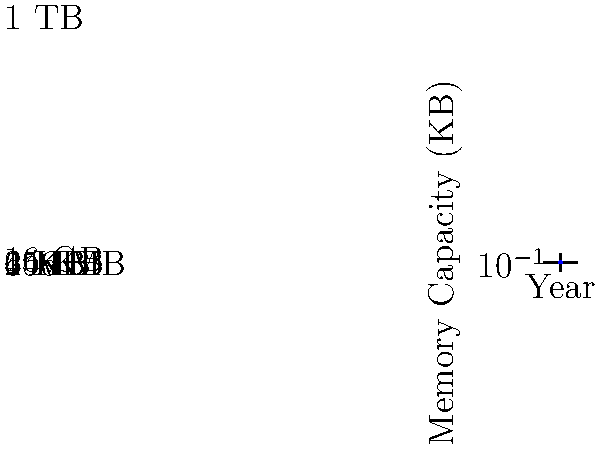As a vintage computer collector, you've observed the evolution of computer memory capacity over time. The graph shows this progression from 1970 to 2020. What was the approximate memory capacity of a typical computer in 1990, and how does this compare to the capacity in 2010? To answer this question, we need to follow these steps:

1. Locate the year 1990 on the x-axis of the graph.
2. Find the corresponding point on the blue line for 1990.
3. Read the memory capacity from the y-axis for this point.
4. Repeat steps 1-3 for the year 2010.
5. Compare the two values.

Following these steps:

1. We find 1990 on the x-axis.
2. The blue line at 1990 corresponds to a y-value of about 4,096 KB.
3. This equals 4 MB (4,096 KB = 4 MB).
4. For 2010, we find the y-value is about 16,000,000 KB, which is 16 GB.
5. Comparing: 16 GB is 4,000 times larger than 4 MB (16,000 MB / 4 MB = 4,000).

The graph shows an exponential increase in memory capacity over time, which aligns with Moore's Law, a principle well-known in computer hardware development.
Answer: 4 MB in 1990; 16 GB in 2010 (4,000 times larger) 